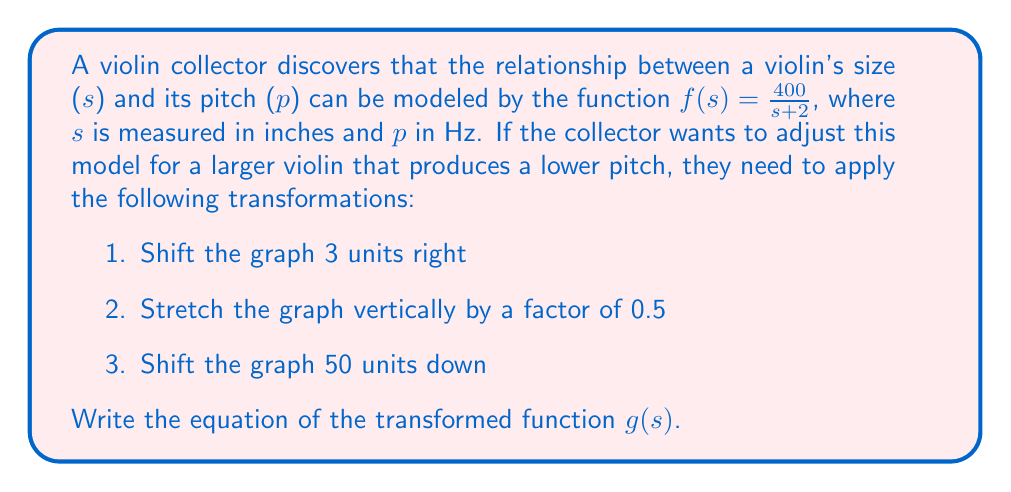Solve this math problem. Let's apply the transformations step by step:

1. Shift 3 units right: Replace s with (s-3)
   $f_1(s) = \frac{400}{(s-3)+2} = \frac{400}{s-1}$

2. Stretch vertically by a factor of 0.5: Multiply the entire function by 0.5
   $f_2(s) = 0.5 \cdot \frac{400}{s-1} = \frac{200}{s-1}$

3. Shift 50 units down: Subtract 50 from the entire function
   $g(s) = \frac{200}{s-1} - 50$

To simplify this further:
$g(s) = \frac{200}{s-1} - \frac{50(s-1)}{s-1} = \frac{200-50(s-1)}{s-1}$

$g(s) = \frac{200-50s+50}{s-1} = \frac{250-50s}{s-1}$

Therefore, the final transformed function is:
$g(s) = \frac{250-50s}{s-1}$
Answer: $g(s) = \frac{250-50s}{s-1}$ 